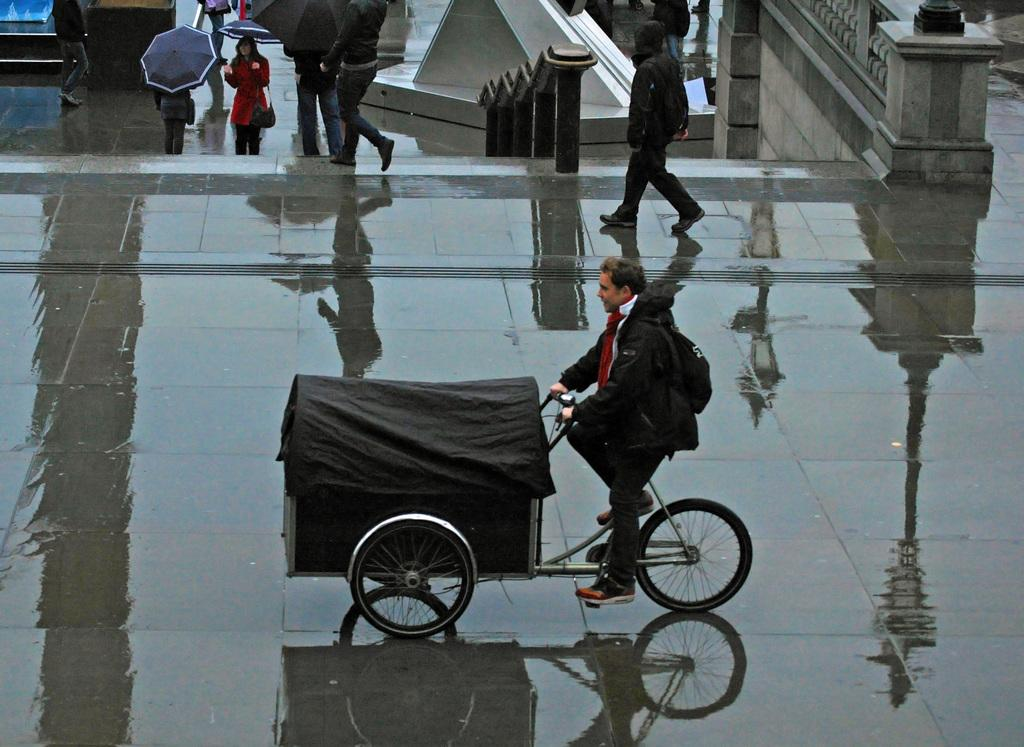What is the person in the image doing? The person is sitting on a vehicle and cycling it. What type of vehicle is the person using? The type of vehicle is not specified, but it is being cycled. What can be seen in the background of the image? There are people walking in the background, and some of them are holding umbrellas. Can you hear the sound of a river flowing in the image? There is no mention of a river or any sound in the image, so it cannot be determined from the image. 